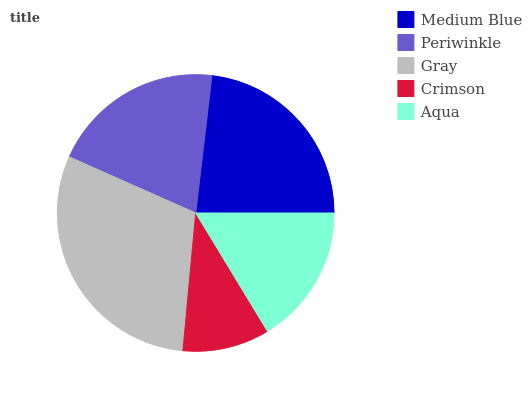Is Crimson the minimum?
Answer yes or no. Yes. Is Gray the maximum?
Answer yes or no. Yes. Is Periwinkle the minimum?
Answer yes or no. No. Is Periwinkle the maximum?
Answer yes or no. No. Is Medium Blue greater than Periwinkle?
Answer yes or no. Yes. Is Periwinkle less than Medium Blue?
Answer yes or no. Yes. Is Periwinkle greater than Medium Blue?
Answer yes or no. No. Is Medium Blue less than Periwinkle?
Answer yes or no. No. Is Periwinkle the high median?
Answer yes or no. Yes. Is Periwinkle the low median?
Answer yes or no. Yes. Is Gray the high median?
Answer yes or no. No. Is Medium Blue the low median?
Answer yes or no. No. 